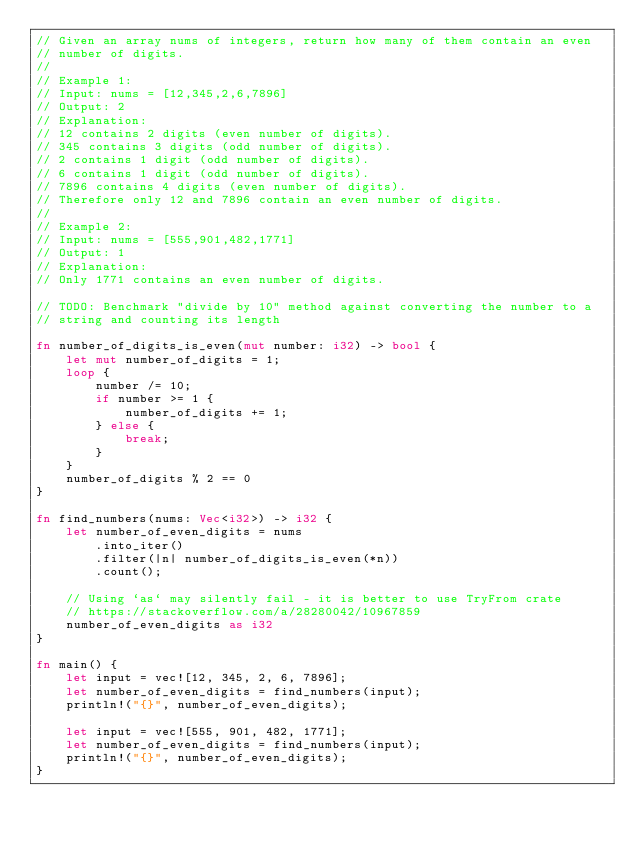Convert code to text. <code><loc_0><loc_0><loc_500><loc_500><_Rust_>// Given an array nums of integers, return how many of them contain an even
// number of digits.
//
// Example 1:
// Input: nums = [12,345,2,6,7896]
// Output: 2
// Explanation:
// 12 contains 2 digits (even number of digits).
// 345 contains 3 digits (odd number of digits).
// 2 contains 1 digit (odd number of digits).
// 6 contains 1 digit (odd number of digits).
// 7896 contains 4 digits (even number of digits).
// Therefore only 12 and 7896 contain an even number of digits.
//
// Example 2:
// Input: nums = [555,901,482,1771]
// Output: 1
// Explanation:
// Only 1771 contains an even number of digits.

// TODO: Benchmark "divide by 10" method against converting the number to a
// string and counting its length

fn number_of_digits_is_even(mut number: i32) -> bool {
    let mut number_of_digits = 1;
    loop {
        number /= 10;
        if number >= 1 {
            number_of_digits += 1;
        } else {
            break;
        }
    }
    number_of_digits % 2 == 0
}

fn find_numbers(nums: Vec<i32>) -> i32 {
    let number_of_even_digits = nums
        .into_iter()
        .filter(|n| number_of_digits_is_even(*n))
        .count();

    // Using `as` may silently fail - it is better to use TryFrom crate
    // https://stackoverflow.com/a/28280042/10967859
    number_of_even_digits as i32
}

fn main() {
    let input = vec![12, 345, 2, 6, 7896];
    let number_of_even_digits = find_numbers(input);
    println!("{}", number_of_even_digits);

    let input = vec![555, 901, 482, 1771];
    let number_of_even_digits = find_numbers(input);
    println!("{}", number_of_even_digits);
}
</code> 